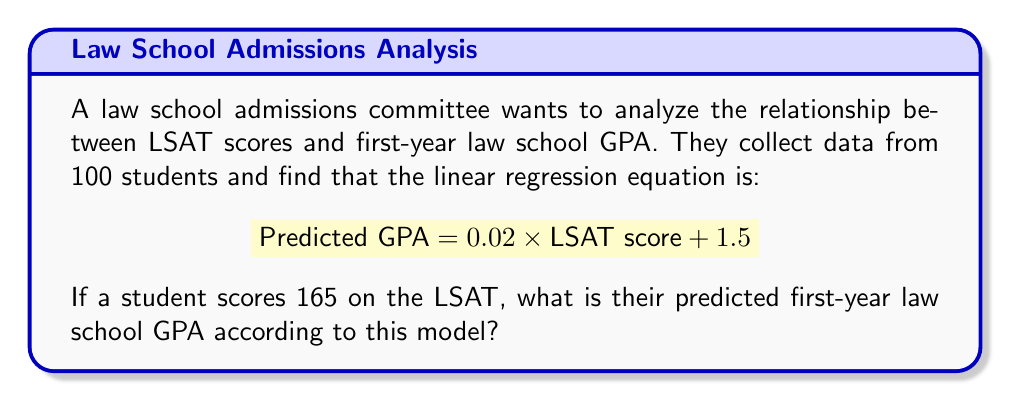Teach me how to tackle this problem. To solve this problem, we'll use the given linear regression equation and substitute the LSAT score:

1. The equation is:
   $$ \text{Predicted GPA} = 0.02 \times \text{LSAT score} + 1.5 $$

2. We're given that the student's LSAT score is 165. Let's substitute this value:
   $$ \text{Predicted GPA} = 0.02 \times 165 + 1.5 $$

3. Now, let's calculate:
   $$ \text{Predicted GPA} = 3.3 + 1.5 $$

4. Finally, we sum up:
   $$ \text{Predicted GPA} = 4.8 $$

Therefore, according to this linear regression model, a student with an LSAT score of 165 is predicted to have a first-year law school GPA of 4.8.
Answer: 4.8 